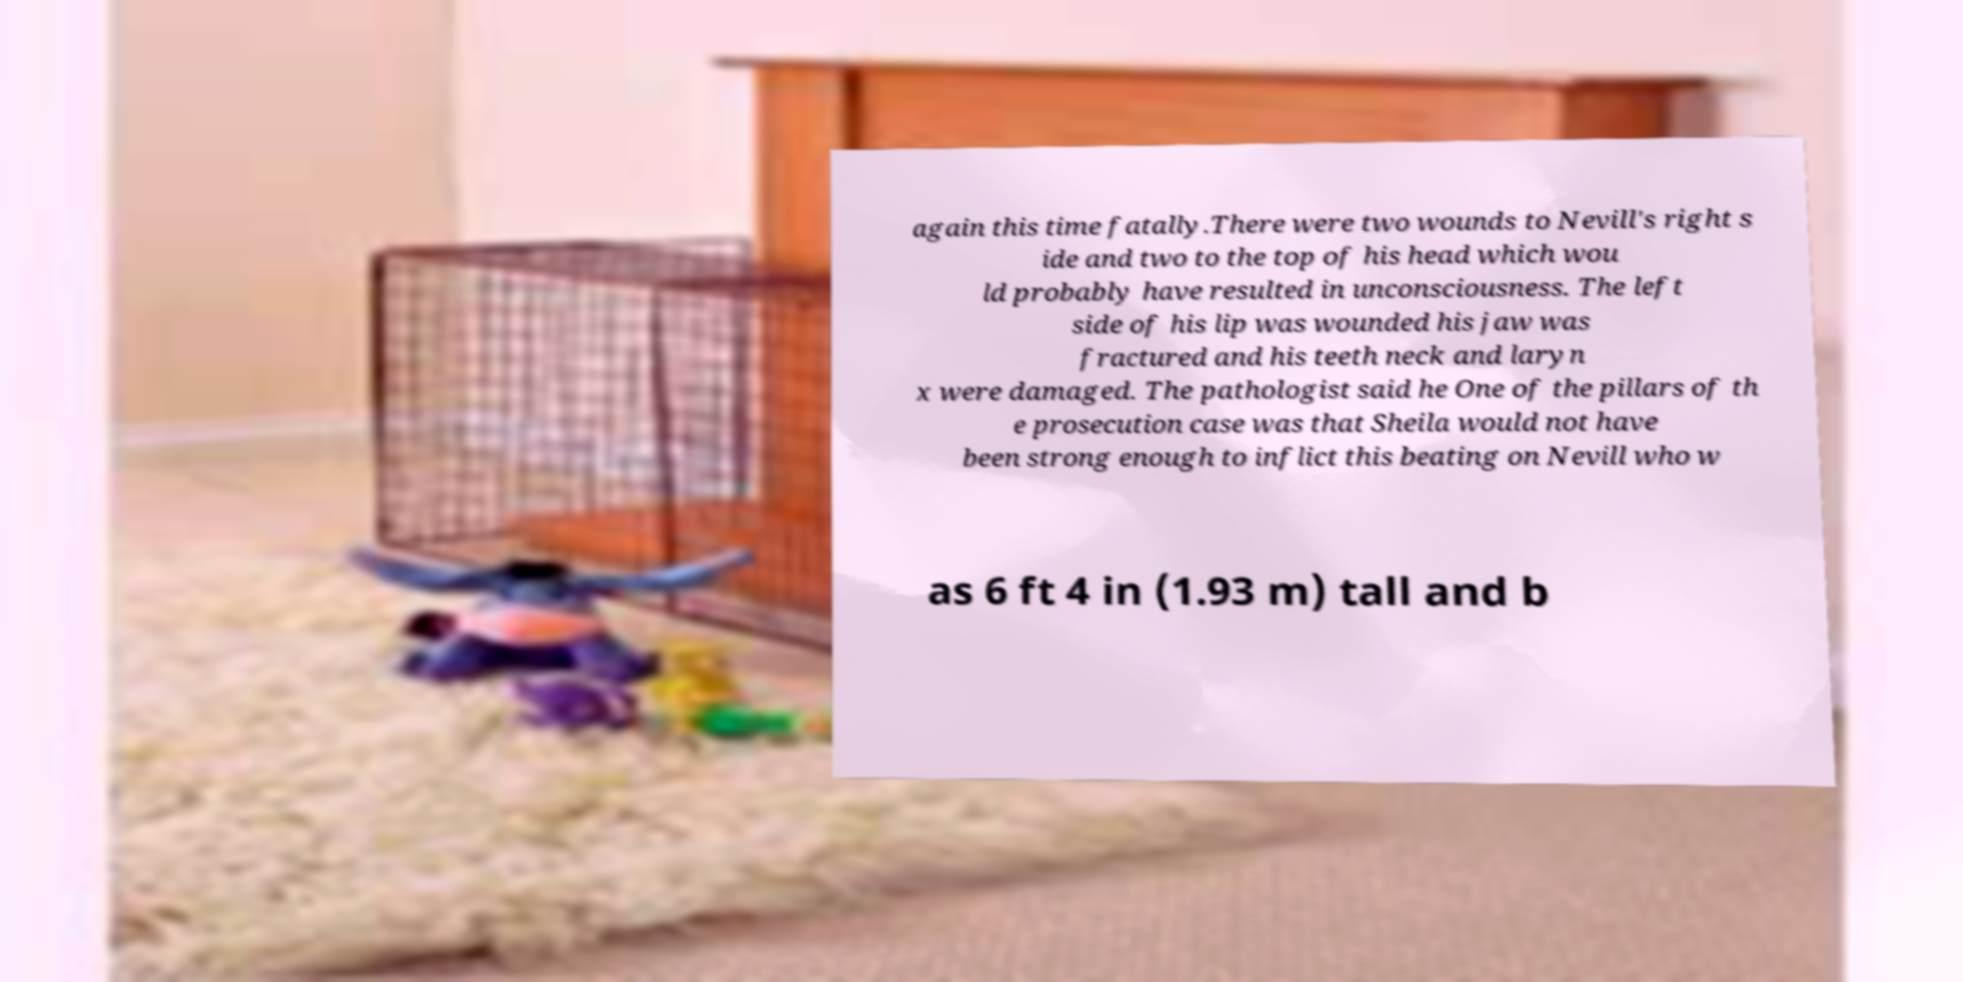Can you read and provide the text displayed in the image?This photo seems to have some interesting text. Can you extract and type it out for me? again this time fatally.There were two wounds to Nevill's right s ide and two to the top of his head which wou ld probably have resulted in unconsciousness. The left side of his lip was wounded his jaw was fractured and his teeth neck and laryn x were damaged. The pathologist said he One of the pillars of th e prosecution case was that Sheila would not have been strong enough to inflict this beating on Nevill who w as 6 ft 4 in (1.93 m) tall and b 